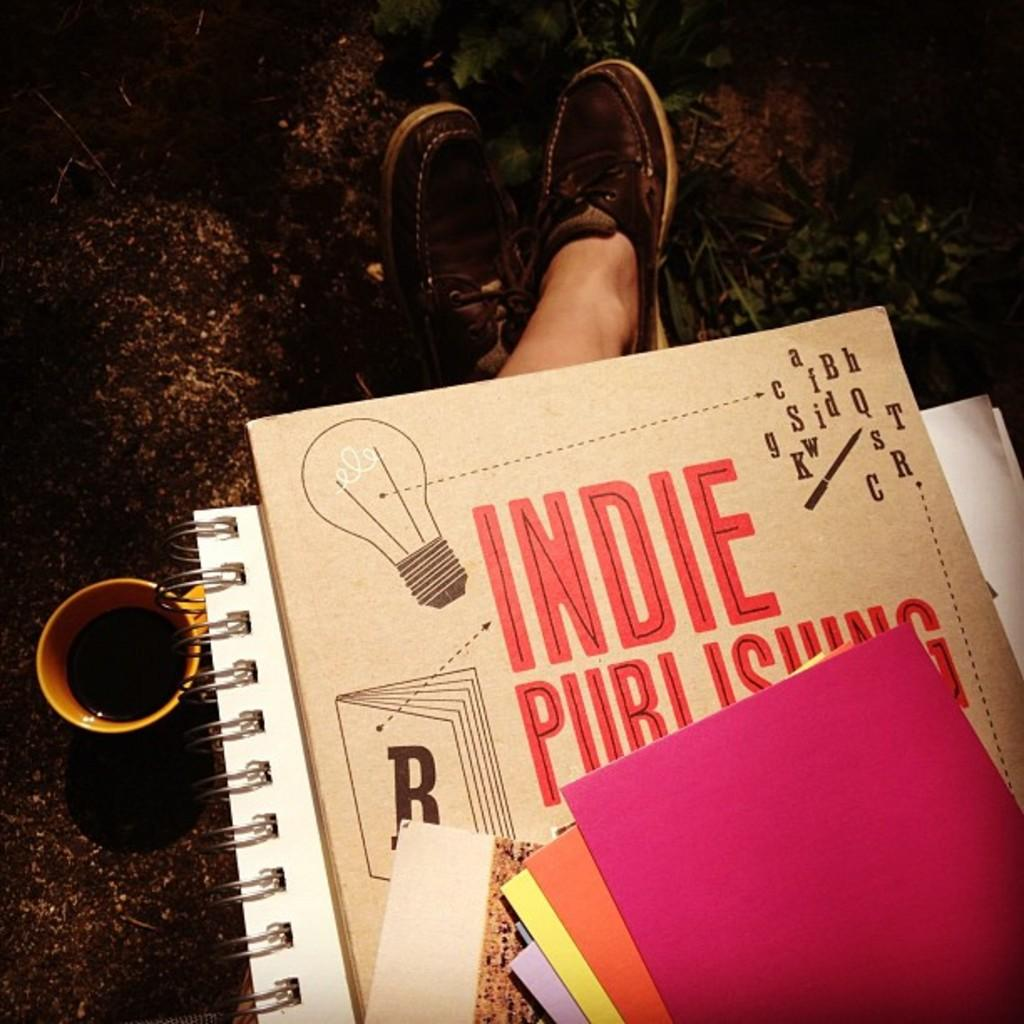Provide a one-sentence caption for the provided image. a view of someone's lap with notebooks and cards reading Indie Publishing. 